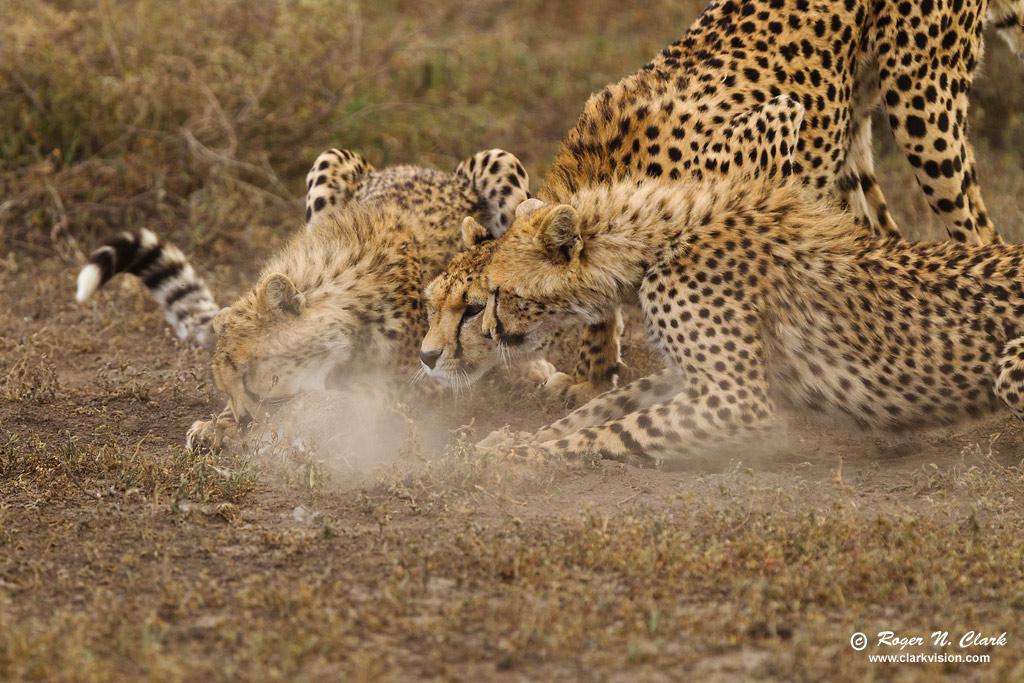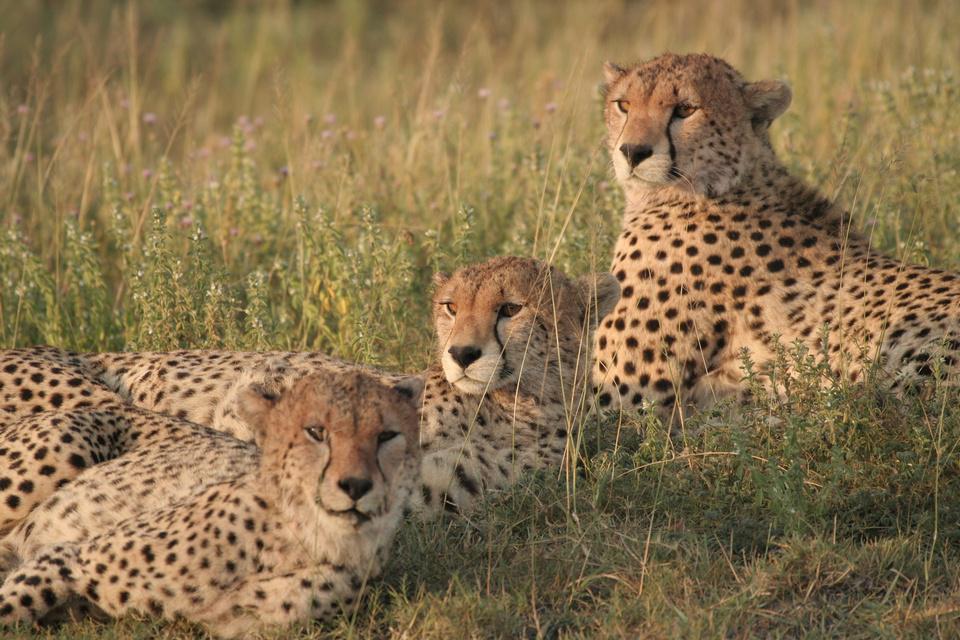The first image is the image on the left, the second image is the image on the right. Given the left and right images, does the statement "In one image there is a single cheetah and in the other there is a single cheetah successfully hunting an antelope." hold true? Answer yes or no. No. The first image is the image on the left, the second image is the image on the right. For the images displayed, is the sentence "One cheetah is capturing a gazelle in the right image, and the left image contains just one cheetah and no prey animal." factually correct? Answer yes or no. No. 